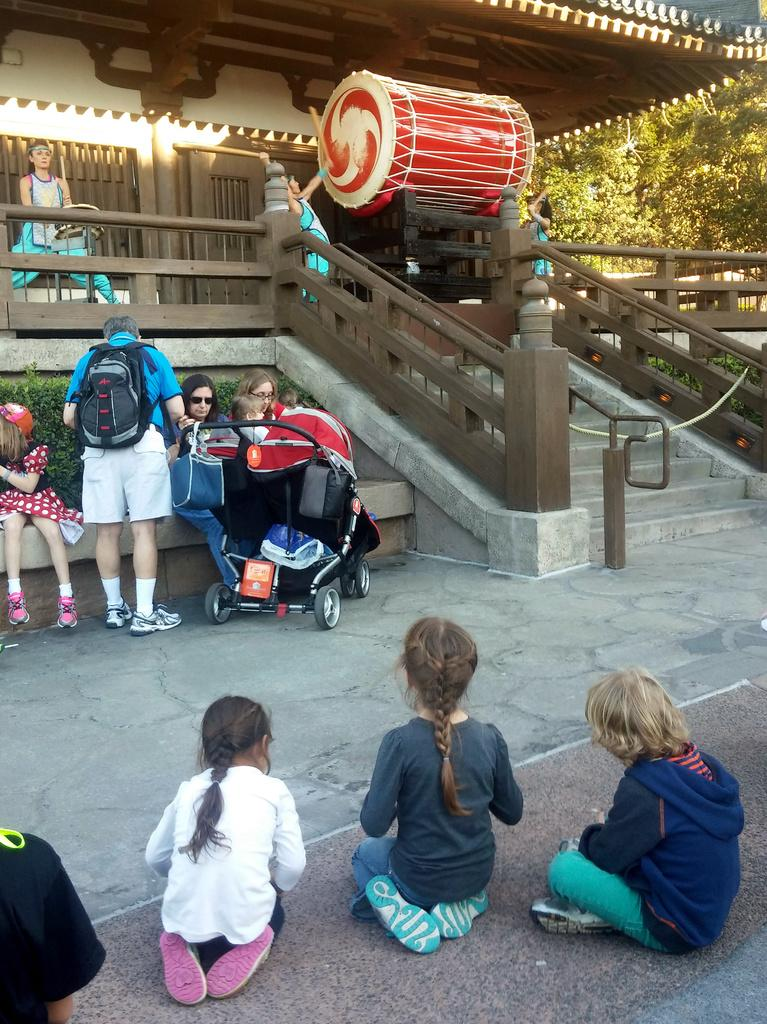What type of structure can be seen in the image? There is a building in the image. What architectural feature is visible in the image? There are stairs in the image. What else can be seen in the image besides the building and stairs? There is a group of people and musical drums present in the image. What type of vegetation is visible in the image? There are trees in the image. What is the average income of the people in the image? The provided facts do not mention any information about the income of the people in the image, so it cannot be determined. Is the image taken in a wilderness setting? The provided facts do not mention any information about the setting being a wilderness, so it cannot be determined. 